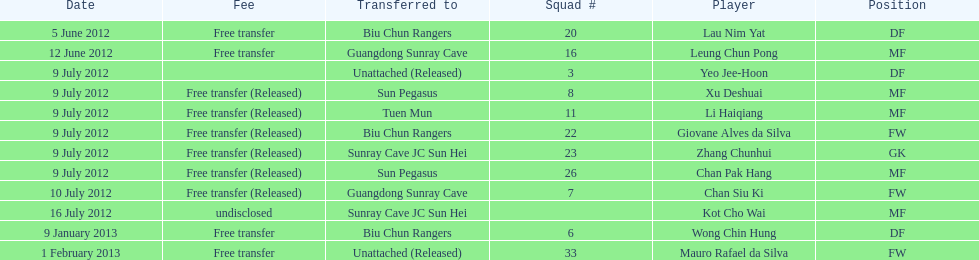Lau nim yat and giovane alves de silva where both transferred to which team? Biu Chun Rangers. 